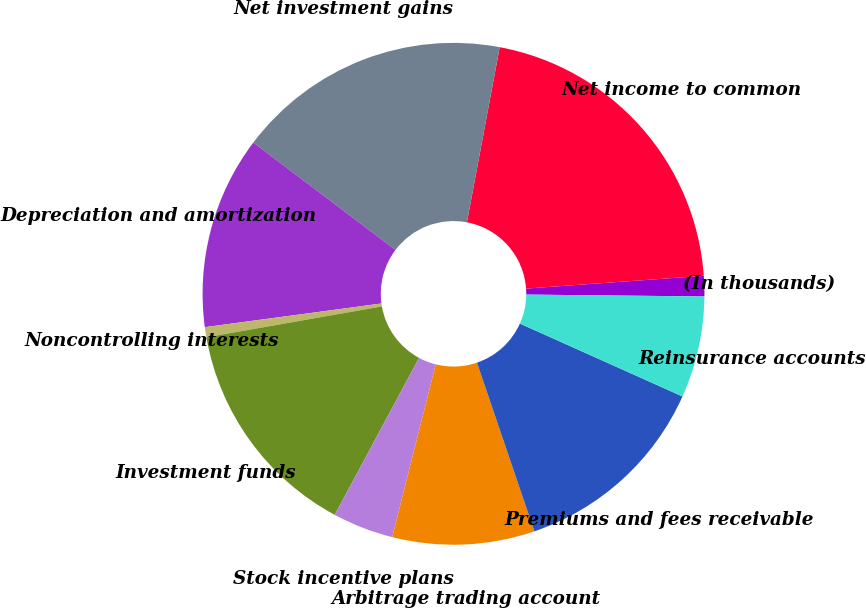Convert chart. <chart><loc_0><loc_0><loc_500><loc_500><pie_chart><fcel>(In thousands)<fcel>Net income to common<fcel>Net investment gains<fcel>Depreciation and amortization<fcel>Noncontrolling interests<fcel>Investment funds<fcel>Stock incentive plans<fcel>Arbitrage trading account<fcel>Premiums and fees receivable<fcel>Reinsurance accounts<nl><fcel>1.31%<fcel>20.91%<fcel>17.65%<fcel>12.42%<fcel>0.65%<fcel>14.38%<fcel>3.92%<fcel>9.15%<fcel>13.07%<fcel>6.54%<nl></chart> 